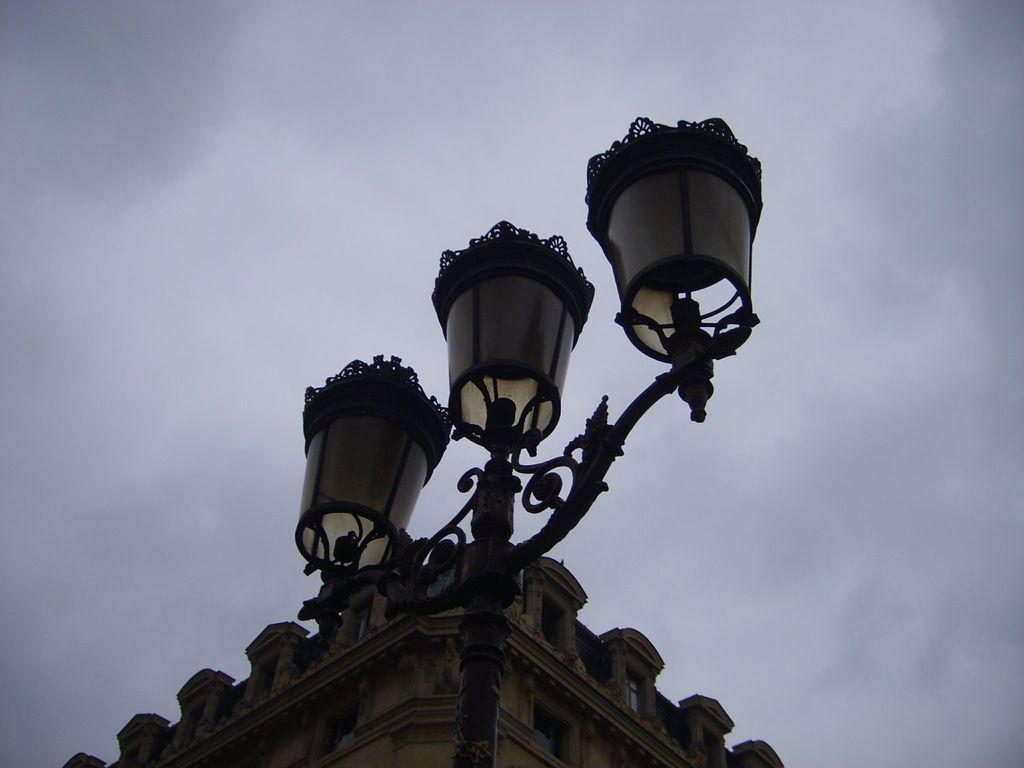In one or two sentences, can you explain what this image depicts? In the picture we can see an upper part of the building and near to it, we can see a pole with three lamps to it and in the background we can see a sky with clouds. 